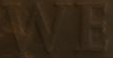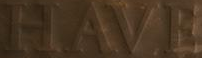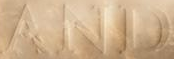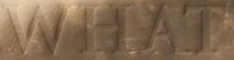Read the text from these images in sequence, separated by a semicolon. WE; HAVE; AND; WHAT 